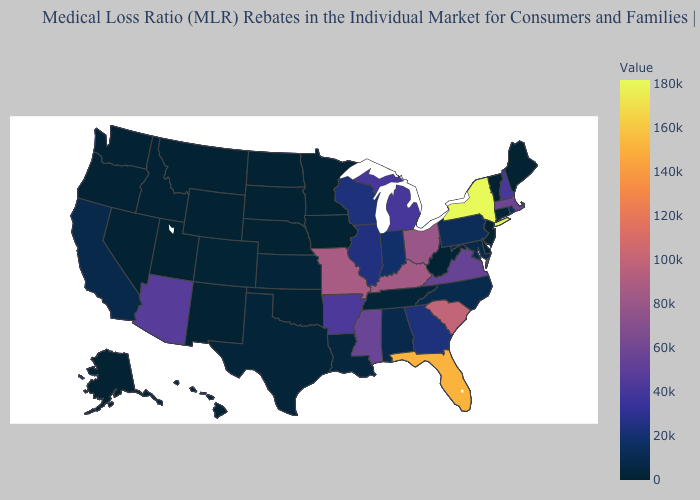Does Delaware have the lowest value in the USA?
Quick response, please. No. Does Florida have the highest value in the South?
Short answer required. Yes. Does South Carolina have a lower value than Massachusetts?
Be succinct. No. Which states have the lowest value in the USA?
Short answer required. Iowa, Maine, Minnesota, Montana, Nebraska, New Jersey, North Dakota, South Dakota, Utah, Vermont, Wyoming. Does Texas have the highest value in the USA?
Concise answer only. No. 